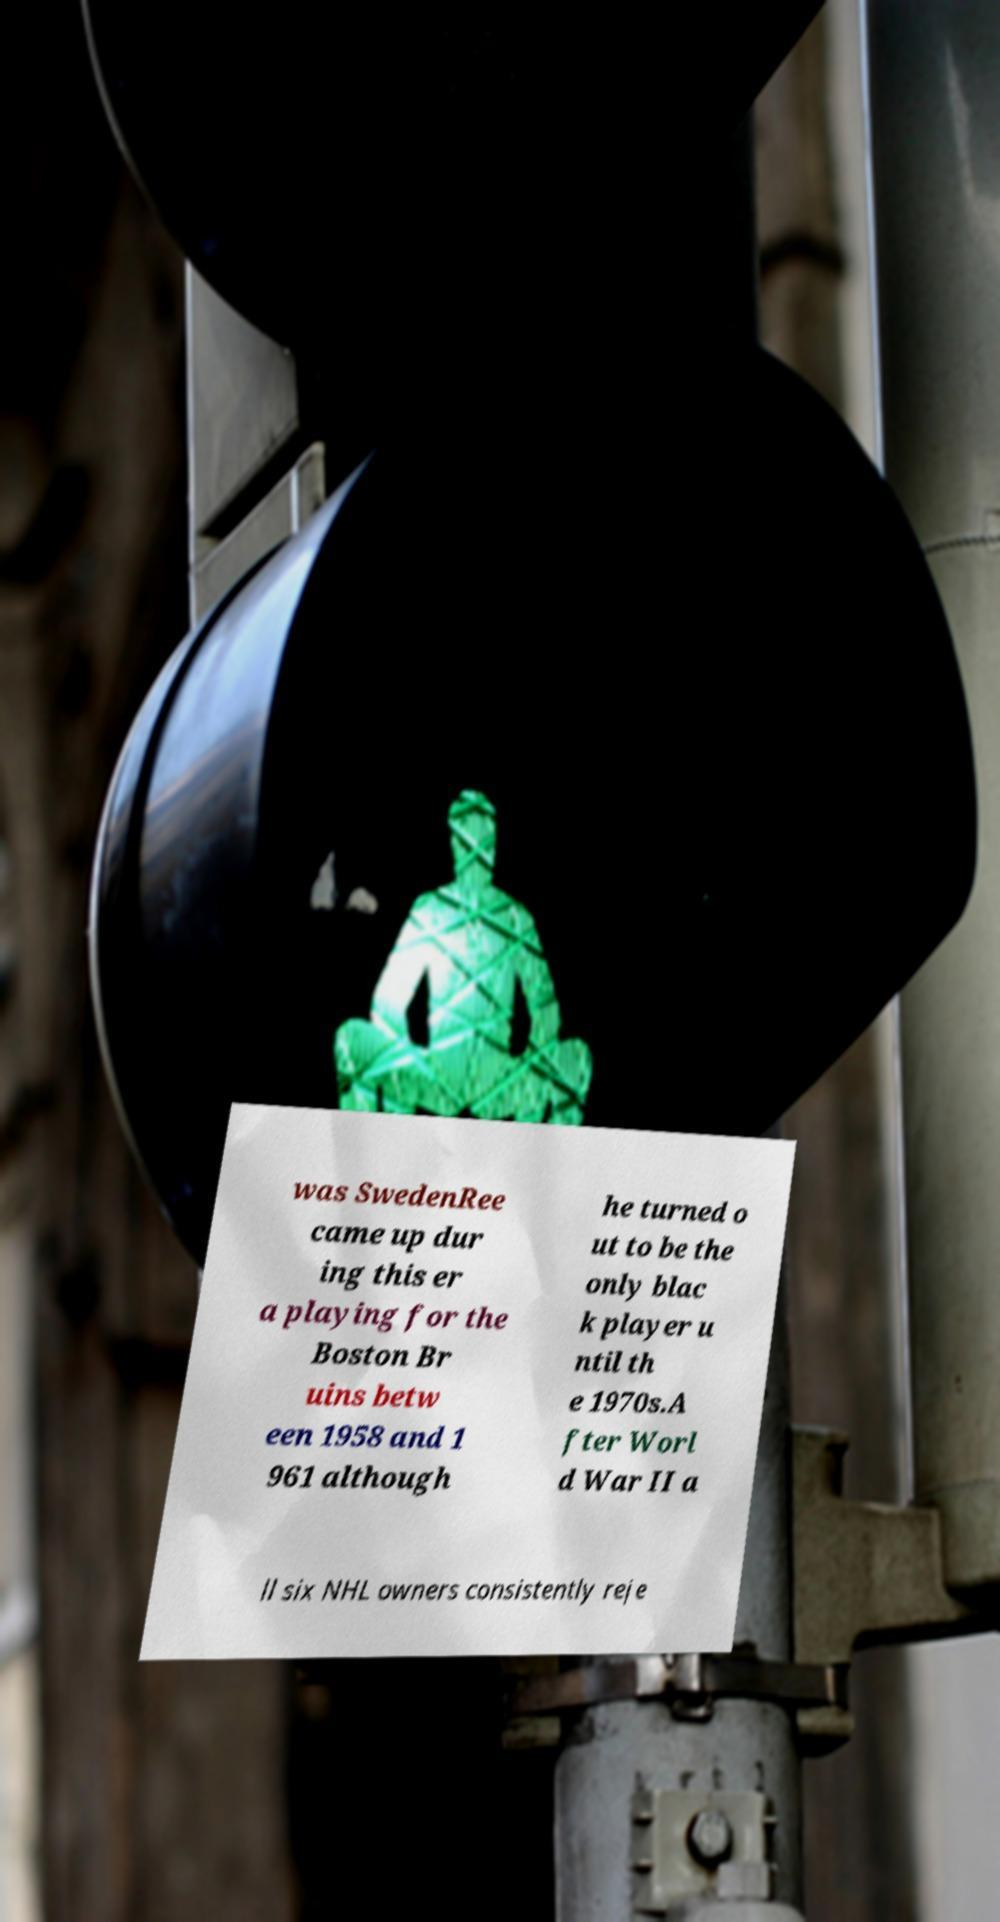There's text embedded in this image that I need extracted. Can you transcribe it verbatim? was SwedenRee came up dur ing this er a playing for the Boston Br uins betw een 1958 and 1 961 although he turned o ut to be the only blac k player u ntil th e 1970s.A fter Worl d War II a ll six NHL owners consistently reje 